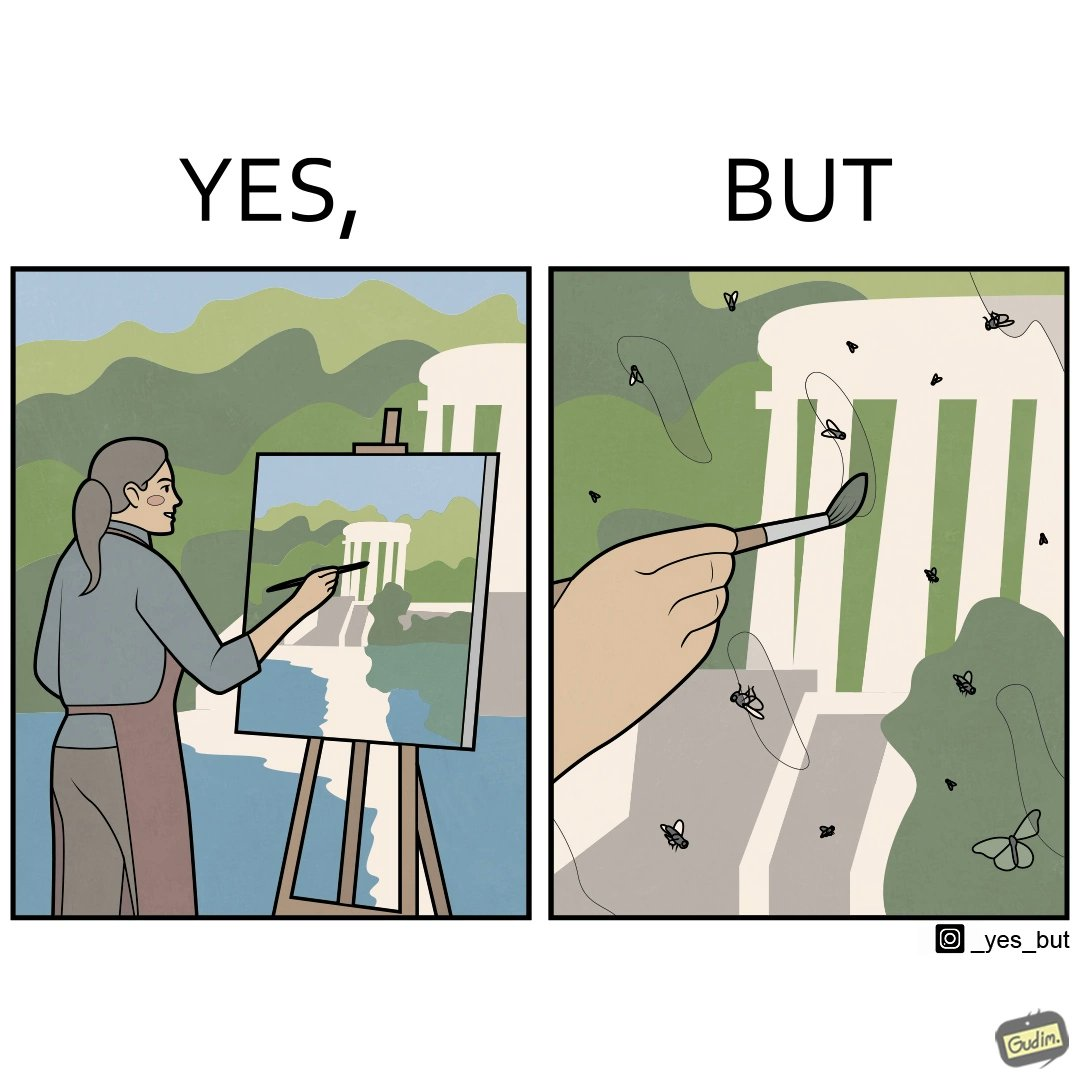What is shown in the left half versus the right half of this image? In the left part of the image: It is a woman painting a natural scenery In the right part of the image: A number of flies stuck on a painting 